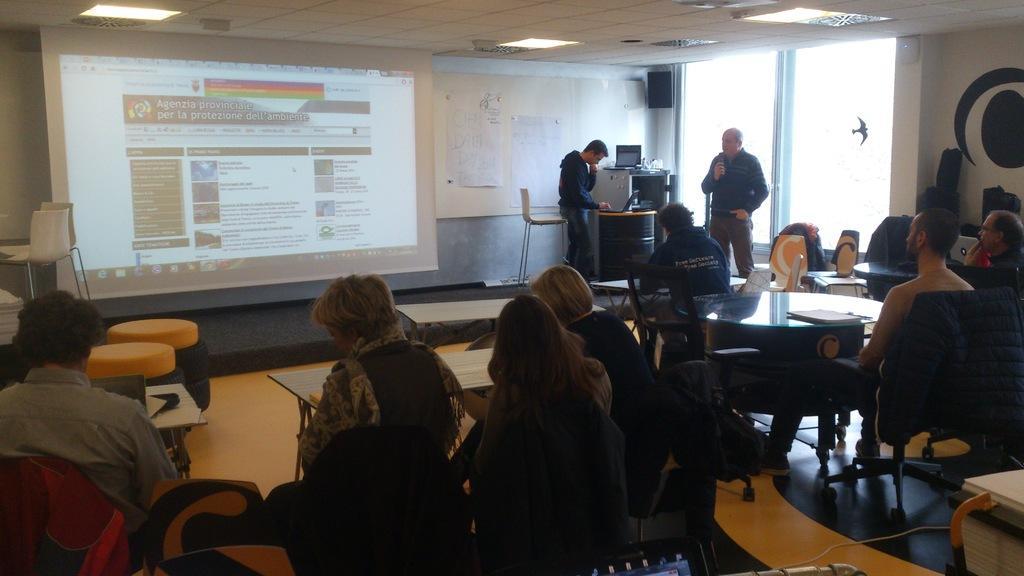In one or two sentences, can you explain what this image depicts? In the picture I can see people among them some are standing and some are sitting on chairs in front of tables. On the tables I can see some objects. In the background I can see a projector screen, board attached to the wall, chairs, lights on the ceiling and some other objects. 